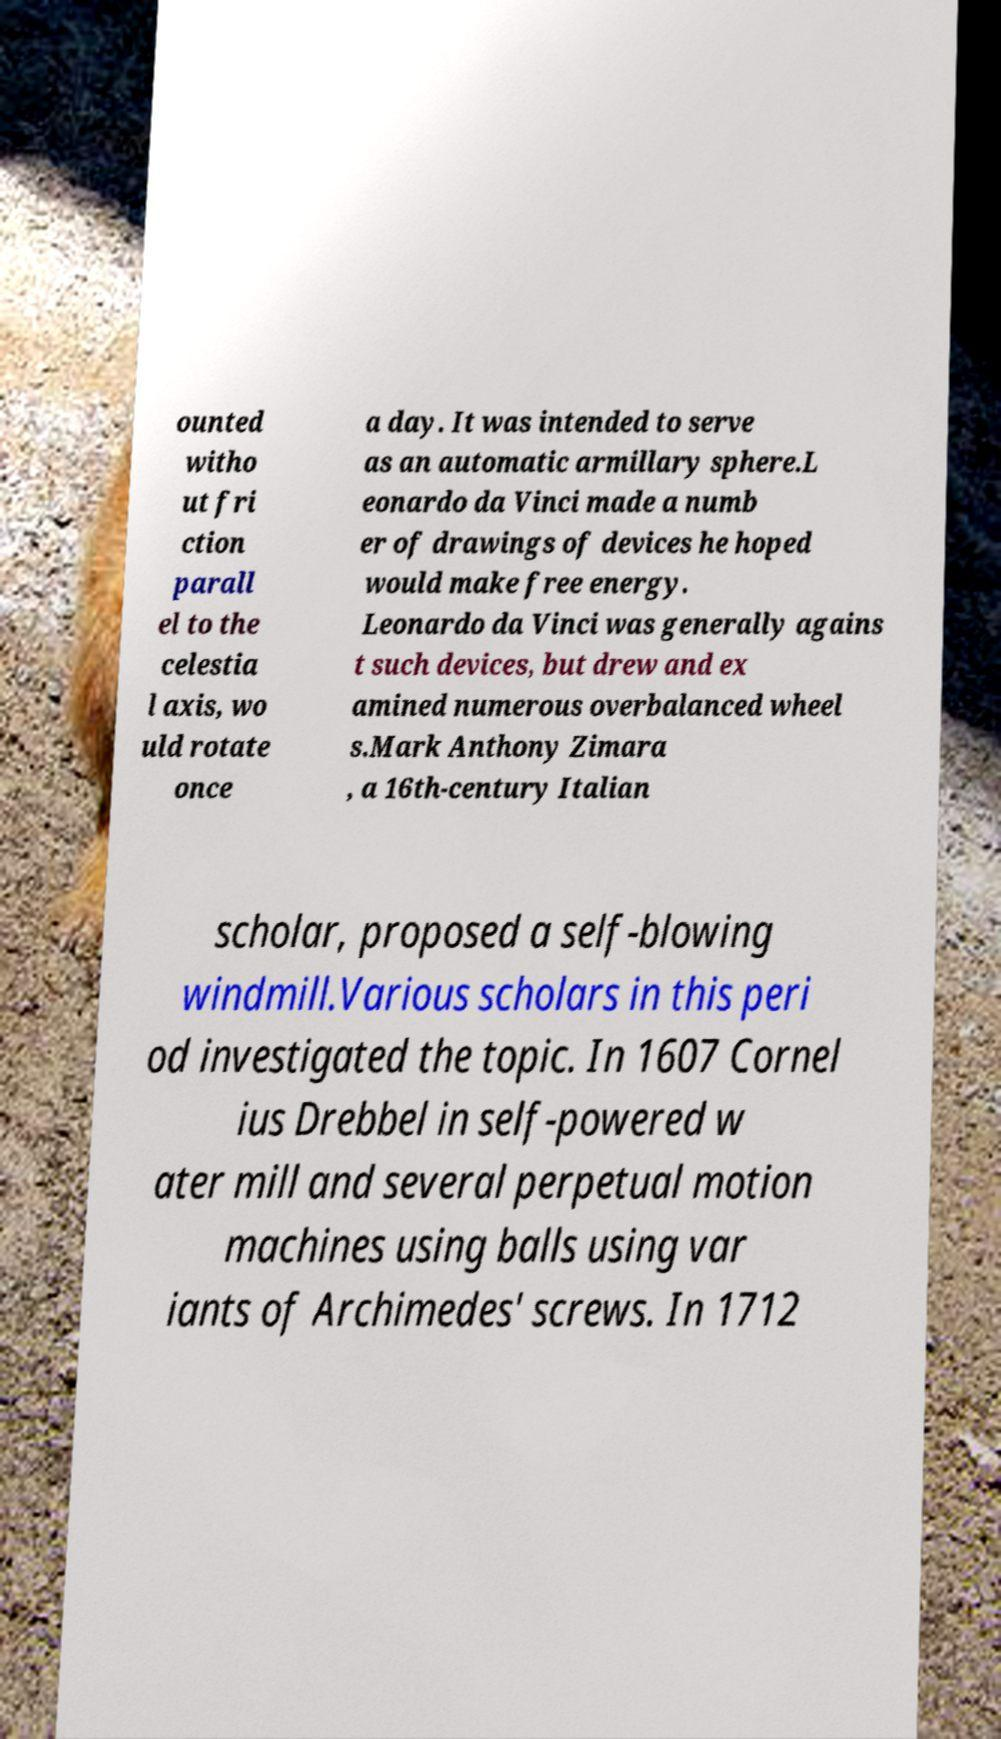For documentation purposes, I need the text within this image transcribed. Could you provide that? ounted witho ut fri ction parall el to the celestia l axis, wo uld rotate once a day. It was intended to serve as an automatic armillary sphere.L eonardo da Vinci made a numb er of drawings of devices he hoped would make free energy. Leonardo da Vinci was generally agains t such devices, but drew and ex amined numerous overbalanced wheel s.Mark Anthony Zimara , a 16th-century Italian scholar, proposed a self-blowing windmill.Various scholars in this peri od investigated the topic. In 1607 Cornel ius Drebbel in self-powered w ater mill and several perpetual motion machines using balls using var iants of Archimedes' screws. In 1712 